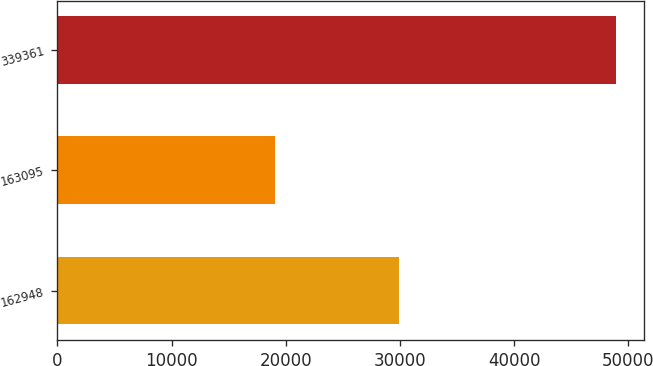<chart> <loc_0><loc_0><loc_500><loc_500><bar_chart><fcel>162948<fcel>163095<fcel>339361<nl><fcel>29942<fcel>19021<fcel>48963<nl></chart> 